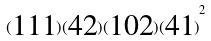Convert formula to latex. <formula><loc_0><loc_0><loc_500><loc_500>( \begin{matrix} 1 1 1 \end{matrix} ) ( \begin{matrix} 4 2 \end{matrix} ) ( \begin{matrix} 1 0 2 \end{matrix} ) { ( \begin{matrix} 4 1 \end{matrix} ) } ^ { 2 }</formula> 